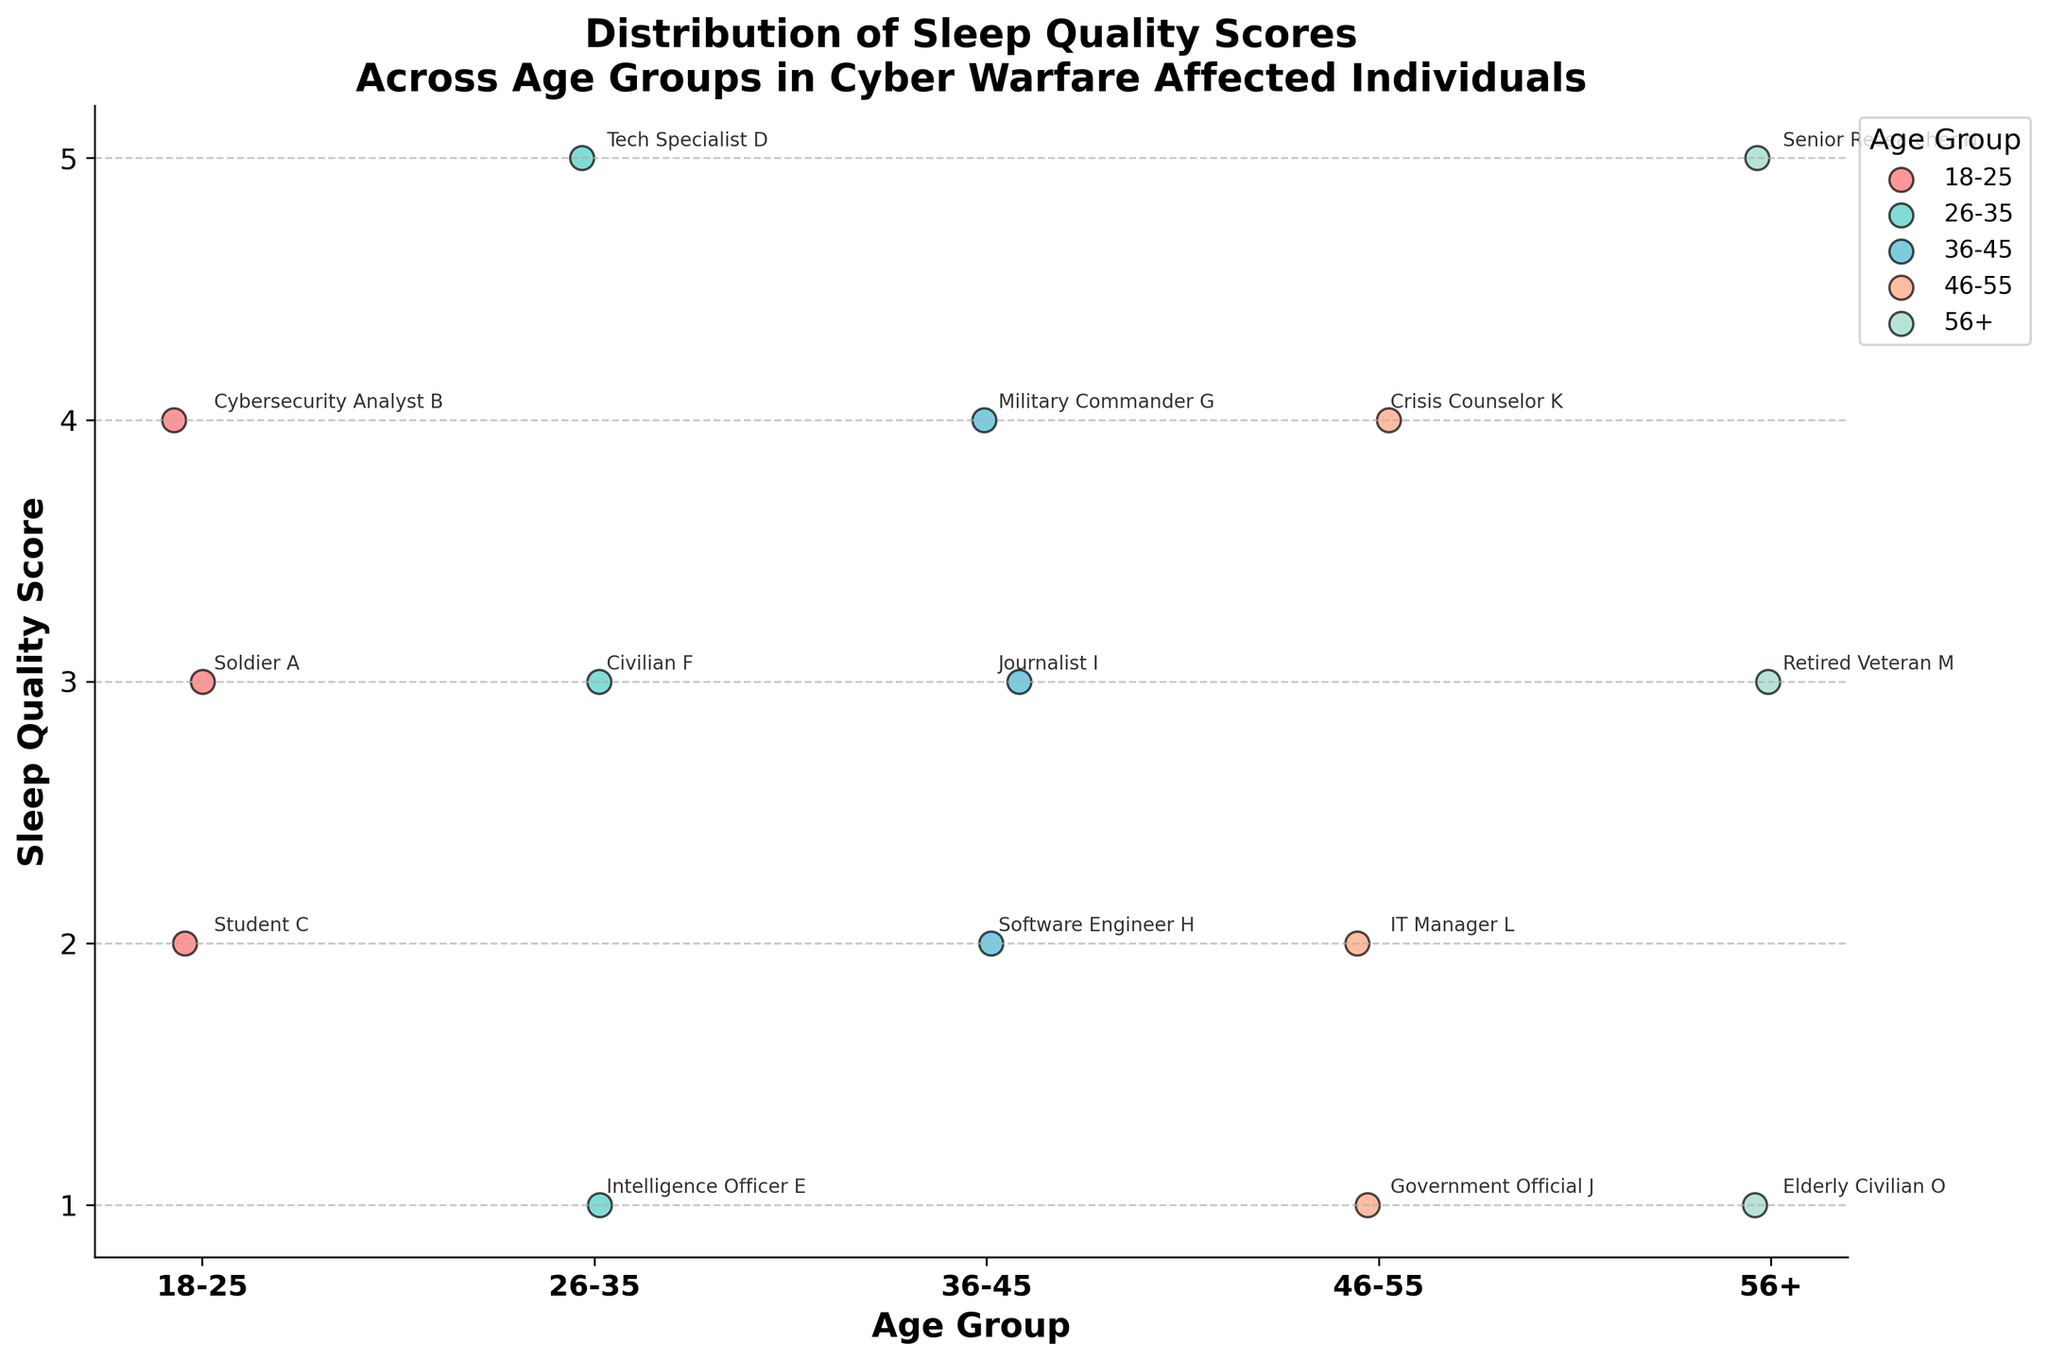Which age group has the highest sleep quality score? By observing the strip plot, look for the highest value on the y-axis, which corresponds to the sleep quality score of 5. Then, identify the age group that it is in.
Answer: 26-35 and 56+ How many individuals in the 36-45 age group have a sleep quality score of 3? Locate the strip plot section for the 36-45 age group, then count the data points (dots) that align with the sleep quality score of 3.
Answer: 1 What is the range of sleep quality scores in the 46-55 age group? To find the range, identify the minimum and maximum sleep quality scores in the relevant age group. The minimum is 1 and the maximum is 4, thus the range is 4 - 1 = 3.
Answer: 3 Which individual has the lowest sleep quality score in the 18-25 age group? Check the strip plot for the 18-25 age group and find the data point at the lowest position on the y-axis.
Answer: Student C What is the average sleep quality score for the 26-35 age group? Sum the sleep quality scores for all individuals in the 26-35 age group (5, 1, 3). Divide the sum by the number of individuals (3). (5 + 1 + 3) / 3 = 3
Answer: 3 Which age group has the most individuals with a sleep quality score of 4? Scan the plot to identify the age group with the highest number of data points at the score of 4.
Answer: 46-55 Are there any individuals in the 56+ age group with a sleep quality score of 2? Check the strip plot section for the 56+ age group to see if there are any data points at the score of 2.
Answer: No 